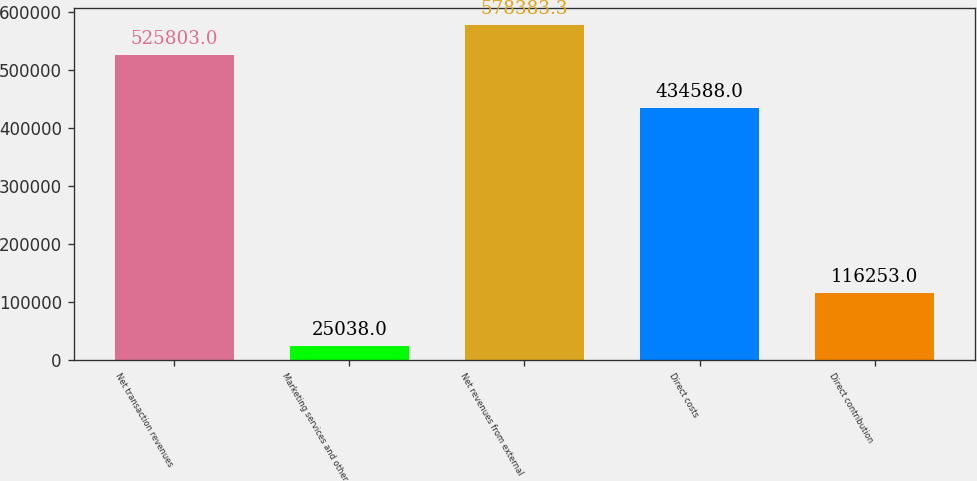Convert chart. <chart><loc_0><loc_0><loc_500><loc_500><bar_chart><fcel>Net transaction revenues<fcel>Marketing services and other<fcel>Net revenues from external<fcel>Direct costs<fcel>Direct contribution<nl><fcel>525803<fcel>25038<fcel>578383<fcel>434588<fcel>116253<nl></chart> 